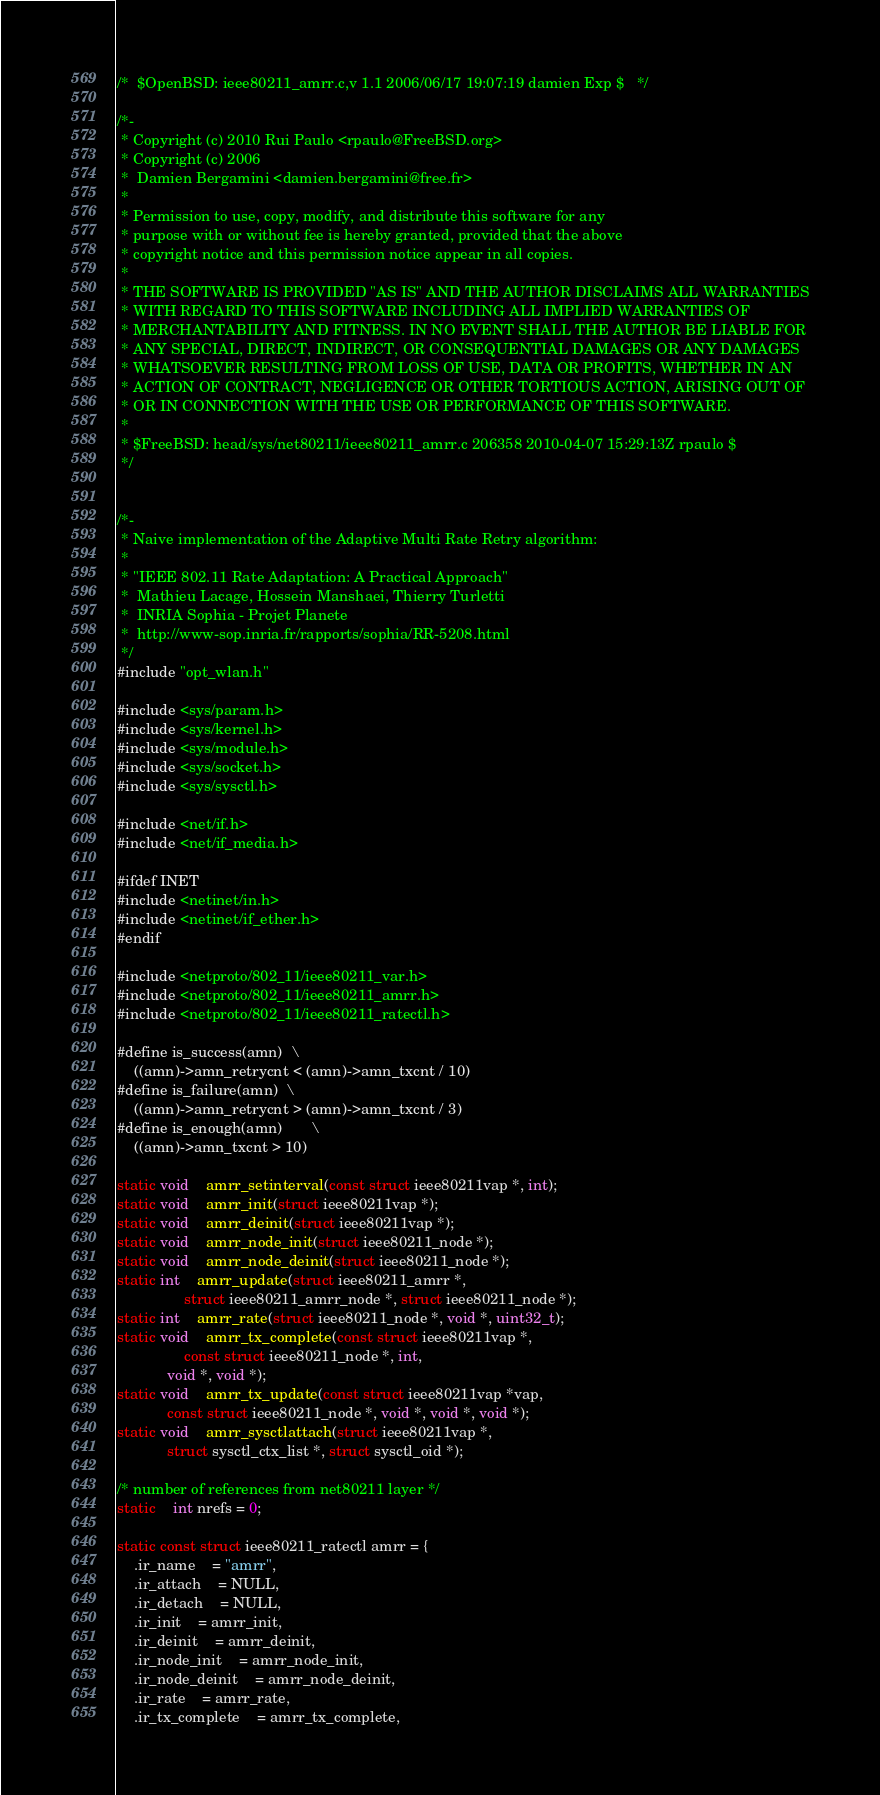<code> <loc_0><loc_0><loc_500><loc_500><_C_>/*	$OpenBSD: ieee80211_amrr.c,v 1.1 2006/06/17 19:07:19 damien Exp $	*/

/*-
 * Copyright (c) 2010 Rui Paulo <rpaulo@FreeBSD.org>
 * Copyright (c) 2006
 *	Damien Bergamini <damien.bergamini@free.fr>
 *
 * Permission to use, copy, modify, and distribute this software for any
 * purpose with or without fee is hereby granted, provided that the above
 * copyright notice and this permission notice appear in all copies.
 *
 * THE SOFTWARE IS PROVIDED "AS IS" AND THE AUTHOR DISCLAIMS ALL WARRANTIES
 * WITH REGARD TO THIS SOFTWARE INCLUDING ALL IMPLIED WARRANTIES OF
 * MERCHANTABILITY AND FITNESS. IN NO EVENT SHALL THE AUTHOR BE LIABLE FOR
 * ANY SPECIAL, DIRECT, INDIRECT, OR CONSEQUENTIAL DAMAGES OR ANY DAMAGES
 * WHATSOEVER RESULTING FROM LOSS OF USE, DATA OR PROFITS, WHETHER IN AN
 * ACTION OF CONTRACT, NEGLIGENCE OR OTHER TORTIOUS ACTION, ARISING OUT OF
 * OR IN CONNECTION WITH THE USE OR PERFORMANCE OF THIS SOFTWARE.
 *
 * $FreeBSD: head/sys/net80211/ieee80211_amrr.c 206358 2010-04-07 15:29:13Z rpaulo $
 */


/*-
 * Naive implementation of the Adaptive Multi Rate Retry algorithm:
 *
 * "IEEE 802.11 Rate Adaptation: A Practical Approach"
 *  Mathieu Lacage, Hossein Manshaei, Thierry Turletti
 *  INRIA Sophia - Projet Planete
 *  http://www-sop.inria.fr/rapports/sophia/RR-5208.html
 */
#include "opt_wlan.h"

#include <sys/param.h>
#include <sys/kernel.h>
#include <sys/module.h>
#include <sys/socket.h>
#include <sys/sysctl.h>

#include <net/if.h>
#include <net/if_media.h>

#ifdef INET
#include <netinet/in.h>
#include <netinet/if_ether.h>
#endif

#include <netproto/802_11/ieee80211_var.h>
#include <netproto/802_11/ieee80211_amrr.h>
#include <netproto/802_11/ieee80211_ratectl.h>

#define is_success(amn)	\
	((amn)->amn_retrycnt < (amn)->amn_txcnt / 10)
#define is_failure(amn)	\
	((amn)->amn_retrycnt > (amn)->amn_txcnt / 3)
#define is_enough(amn)		\
	((amn)->amn_txcnt > 10)

static void	amrr_setinterval(const struct ieee80211vap *, int);
static void	amrr_init(struct ieee80211vap *);
static void	amrr_deinit(struct ieee80211vap *);
static void	amrr_node_init(struct ieee80211_node *);
static void	amrr_node_deinit(struct ieee80211_node *);
static int	amrr_update(struct ieee80211_amrr *,
    			struct ieee80211_amrr_node *, struct ieee80211_node *);
static int	amrr_rate(struct ieee80211_node *, void *, uint32_t);
static void	amrr_tx_complete(const struct ieee80211vap *,
    			const struct ieee80211_node *, int, 
			void *, void *);
static void	amrr_tx_update(const struct ieee80211vap *vap,
			const struct ieee80211_node *, void *, void *, void *);
static void	amrr_sysctlattach(struct ieee80211vap *,
			struct sysctl_ctx_list *, struct sysctl_oid *);

/* number of references from net80211 layer */
static	int nrefs = 0;

static const struct ieee80211_ratectl amrr = {
	.ir_name	= "amrr",
	.ir_attach	= NULL,
	.ir_detach	= NULL,
	.ir_init	= amrr_init,
	.ir_deinit	= amrr_deinit,
	.ir_node_init	= amrr_node_init,
	.ir_node_deinit	= amrr_node_deinit,
	.ir_rate	= amrr_rate,
	.ir_tx_complete	= amrr_tx_complete,</code> 